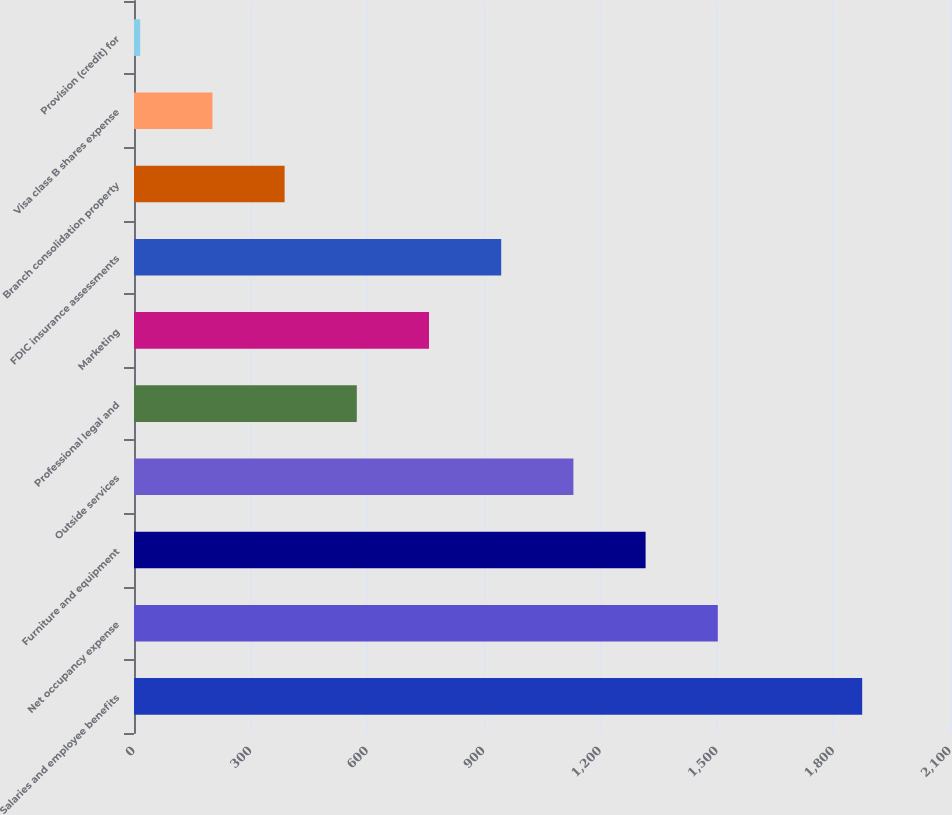Convert chart. <chart><loc_0><loc_0><loc_500><loc_500><bar_chart><fcel>Salaries and employee benefits<fcel>Net occupancy expense<fcel>Furniture and equipment<fcel>Outside services<fcel>Professional legal and<fcel>Marketing<fcel>FDIC insurance assessments<fcel>Branch consolidation property<fcel>Visa class B shares expense<fcel>Provision (credit) for<nl><fcel>1874<fcel>1502.4<fcel>1316.6<fcel>1130.8<fcel>573.4<fcel>759.2<fcel>945<fcel>387.6<fcel>201.8<fcel>16<nl></chart> 